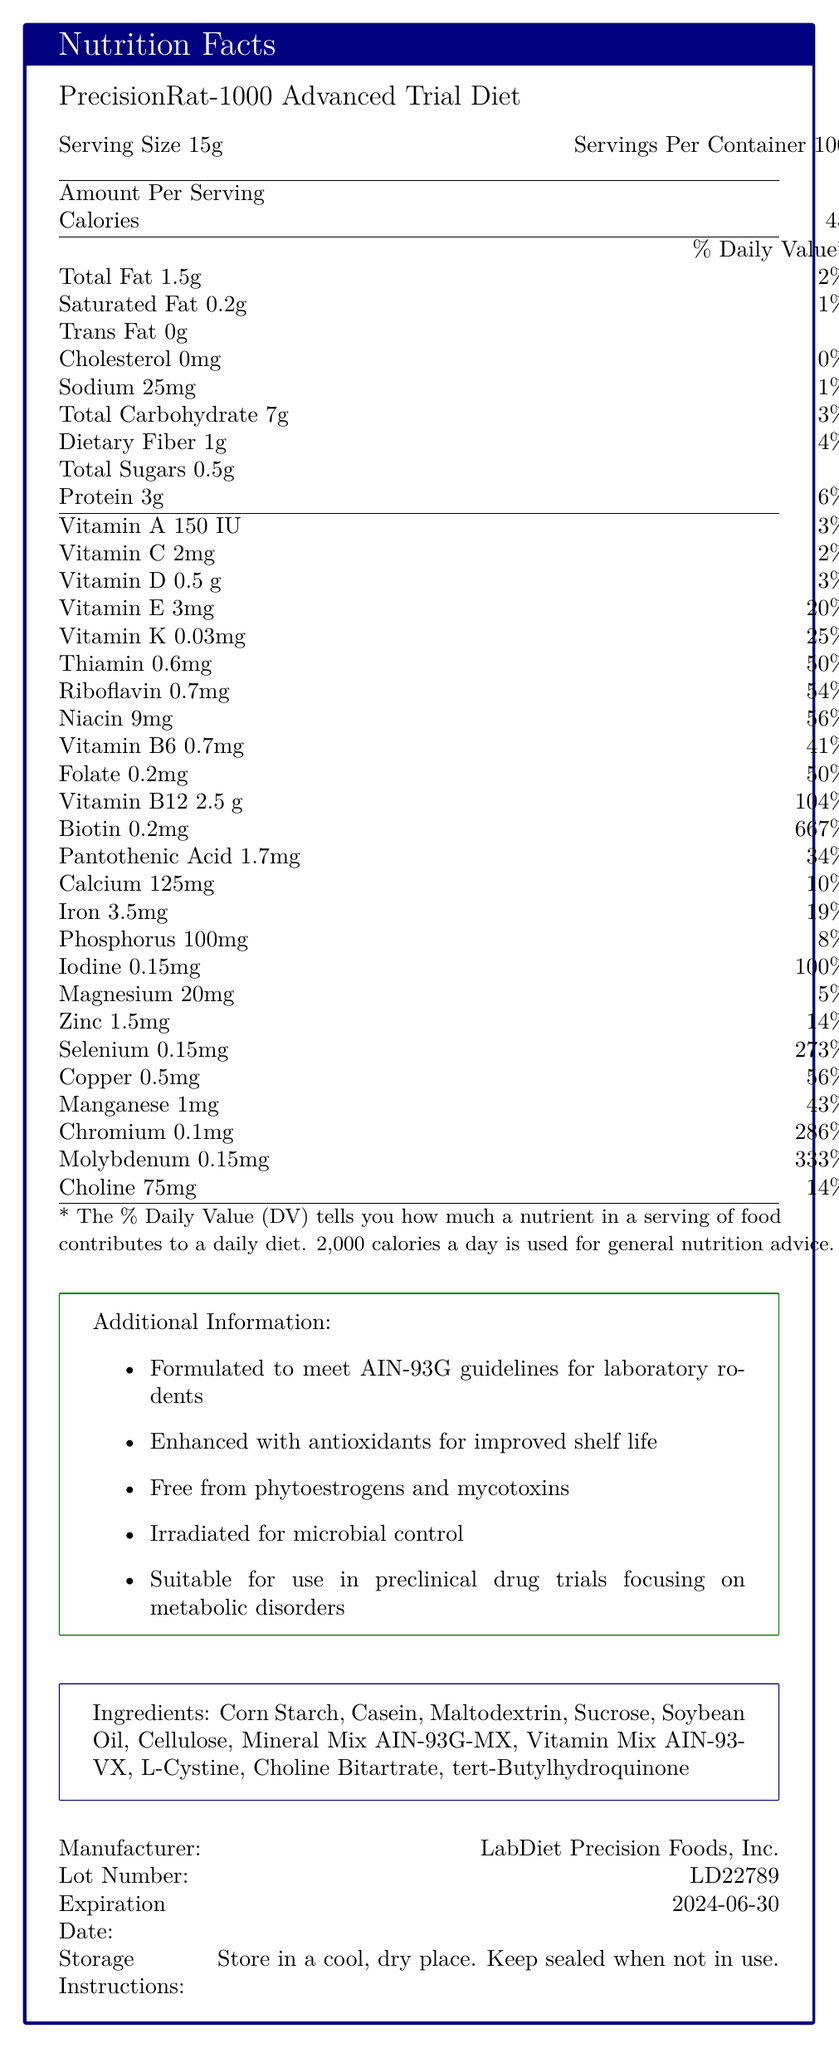what is the serving size? The serving size is explicitly listed as 15g in the document.
Answer: 15g how many servings are there per container? The number of servings per container is shown as 100.
Answer: 100 what percentage of the daily value of protein is provided per serving? The document states that a serving provides 6% of the daily value for protein.
Answer: 6% which vitamin has the highest daily value percentage per serving? Biotin has a daily value percentage of 667%, which is the highest listed in the document.
Answer: Biotin what is the amount of sodium in a serving? The amount of sodium per serving is 25mg as shown in the document.
Answer: 25mg which ingredient is listed first in the ingredient list? The first ingredient listed is Corn Starch.
Answer: Corn Starch what is the expiration date of the PrecisionRat-1000 Advanced Trial Diet? The expiration date is explicitly provided as 2024-06-30.
Answer: 2024-06-30 how much dietary fiber is in one serving? The dietary fiber content per serving is 1g.
Answer: 1g how many calories are there in one serving? One serving contains 45 calories.
Answer: 45 how much iodine is present per serving? The document lists the iodine content as 0.15mg per serving.
Answer: 0.15mg which vitamin has a daily value percentage of 25% per serving? A. Vitamin K B. Vitamin A C. Vitamin C D. Vitamin D The document shows that Vitamin K has a daily value percentage of 25% per serving.
Answer: A. Vitamin K Based on the document, which of the following statements is true? A. The diet is suitable for rodents with phytoestrogen sensitivity. B. The diet contains mycotoxins. C. The diet does not use antioxidants. The additional information specifies that the diet is free from phytoestrogens and mycotoxins and is enhanced with antioxidants.
Answer: A. The diet is suitable for rodents with phytoestrogen sensitivity Is the diet free from phytoestrogens? The document states that the diet is free from phytoestrogens.
Answer: Yes Can you determine the cost of the PrecisionRat-1000 Advanced Trial Diet from the document? The document does not provide any information regarding the cost of the diet.
Answer: Cannot be determined Summarize the main components and features of the PrecisionRat-1000 Advanced Trial Diet described in the document. The explanation should concisely cover the full scope of the nutritional information, additional product features, and handling instructions provided in the document.
Answer: The PrecisionRat-1000 Advanced Trial Diet is a specialized rodent diet designed for preclinical drug trials, especially for metabolic disorders. Each serving size is 15g, with 100 servings per container. It provides 45 calories per serving and includes a variety of micronutrients with significant daily value percentages, particularly Biotin at 667%. It is formulated to meet AIN-93G guidelines, is free from phytoestrogens and mycotoxins, enhanced with antioxidants, irradiated for microbial control, and includes a list of specific ingredients. The product is manufactured by LabDiet Precision Foods, Inc., with lot number LD22789, and has an expiration date of June 30, 2024. The storage instructions advise keeping the product in a cool, dry place and sealed when not in use. 